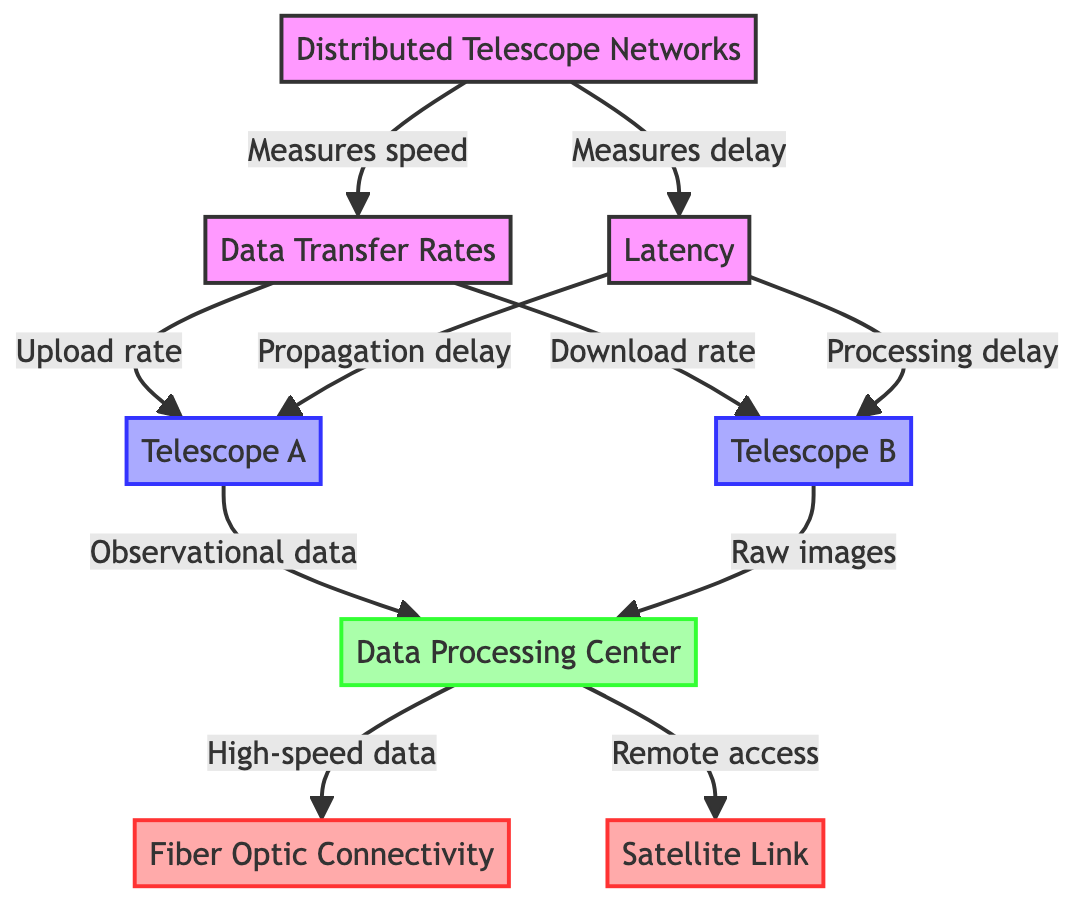What are the two types of measurements taken from the distributed telescope networks? The diagram indicates two types of measurements: speed and delay, which are connected to data transfer rates and latency, respectively.
Answer: speed and delay How many telescopes are represented in the diagram? There are two telescopes illustrated in the diagram, named Telescope A and Telescope B.
Answer: two What connects the data processing center to Fiber Optic Connectivity? The connection is established through high-speed data being transmitted from the data processing center to the fiber optic connectivity node.
Answer: high-speed data Which type of connectivity allows for remote access? The diagram shows that remote access is made possible through a satellite link that connects to the data processing center.
Answer: satellite link What two types of data are sent to the data processing center from the telescopes? The data processing center receives observational data from Telescope A and raw images from Telescope B.
Answer: observational data and raw images What type of delay corresponds to Telescope A? The propagation delay is the delay associated with Telescope A as indicated in the connections to latency from the telescope node.
Answer: propagation delay Which node receives uploads from Telescope A? Telescope A sends observational data to the data processing center, which is the receiving node for the uploads.
Answer: data processing center How does the diagram categorize the connectivity types? The diagram categorizes the connectivity types into fiber optic and satellite link, both distinguished by their respective symbols and colors.
Answer: fiber optic and satellite link What is the relationship between latency and the telescopes in the diagram? Latency is measured in relation to both telescopes, as indicated by the connections from each telescope to the latency node through their respective delays.
Answer: measured by both telescopes 